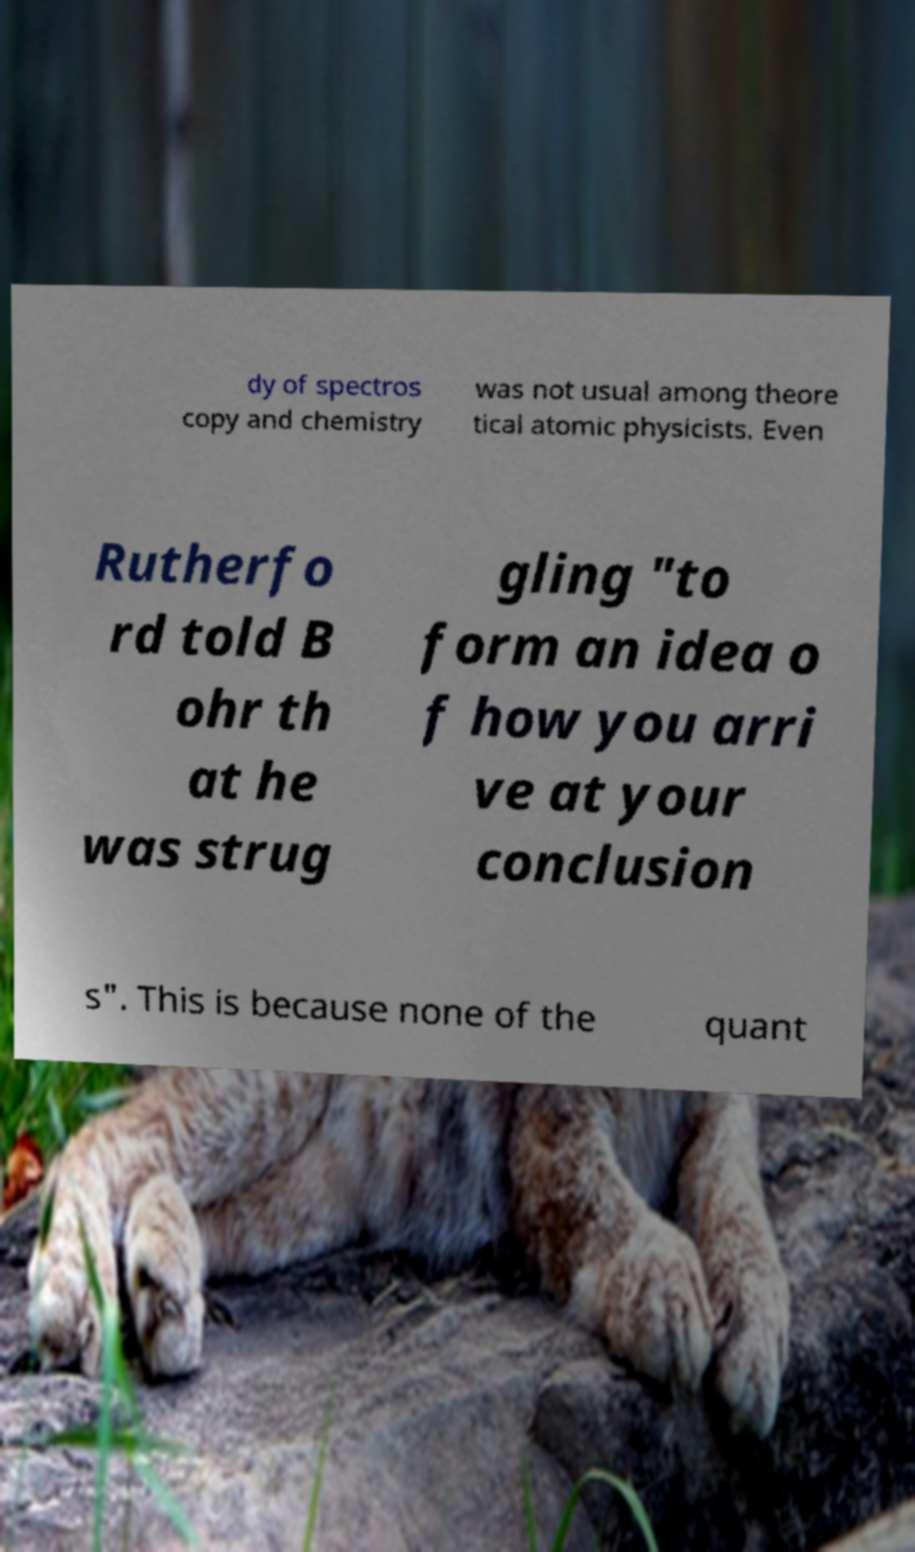Could you extract and type out the text from this image? dy of spectros copy and chemistry was not usual among theore tical atomic physicists. Even Rutherfo rd told B ohr th at he was strug gling "to form an idea o f how you arri ve at your conclusion s". This is because none of the quant 